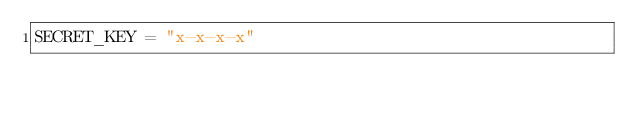<code> <loc_0><loc_0><loc_500><loc_500><_Python_>SECRET_KEY = "x-x-x-x"</code> 